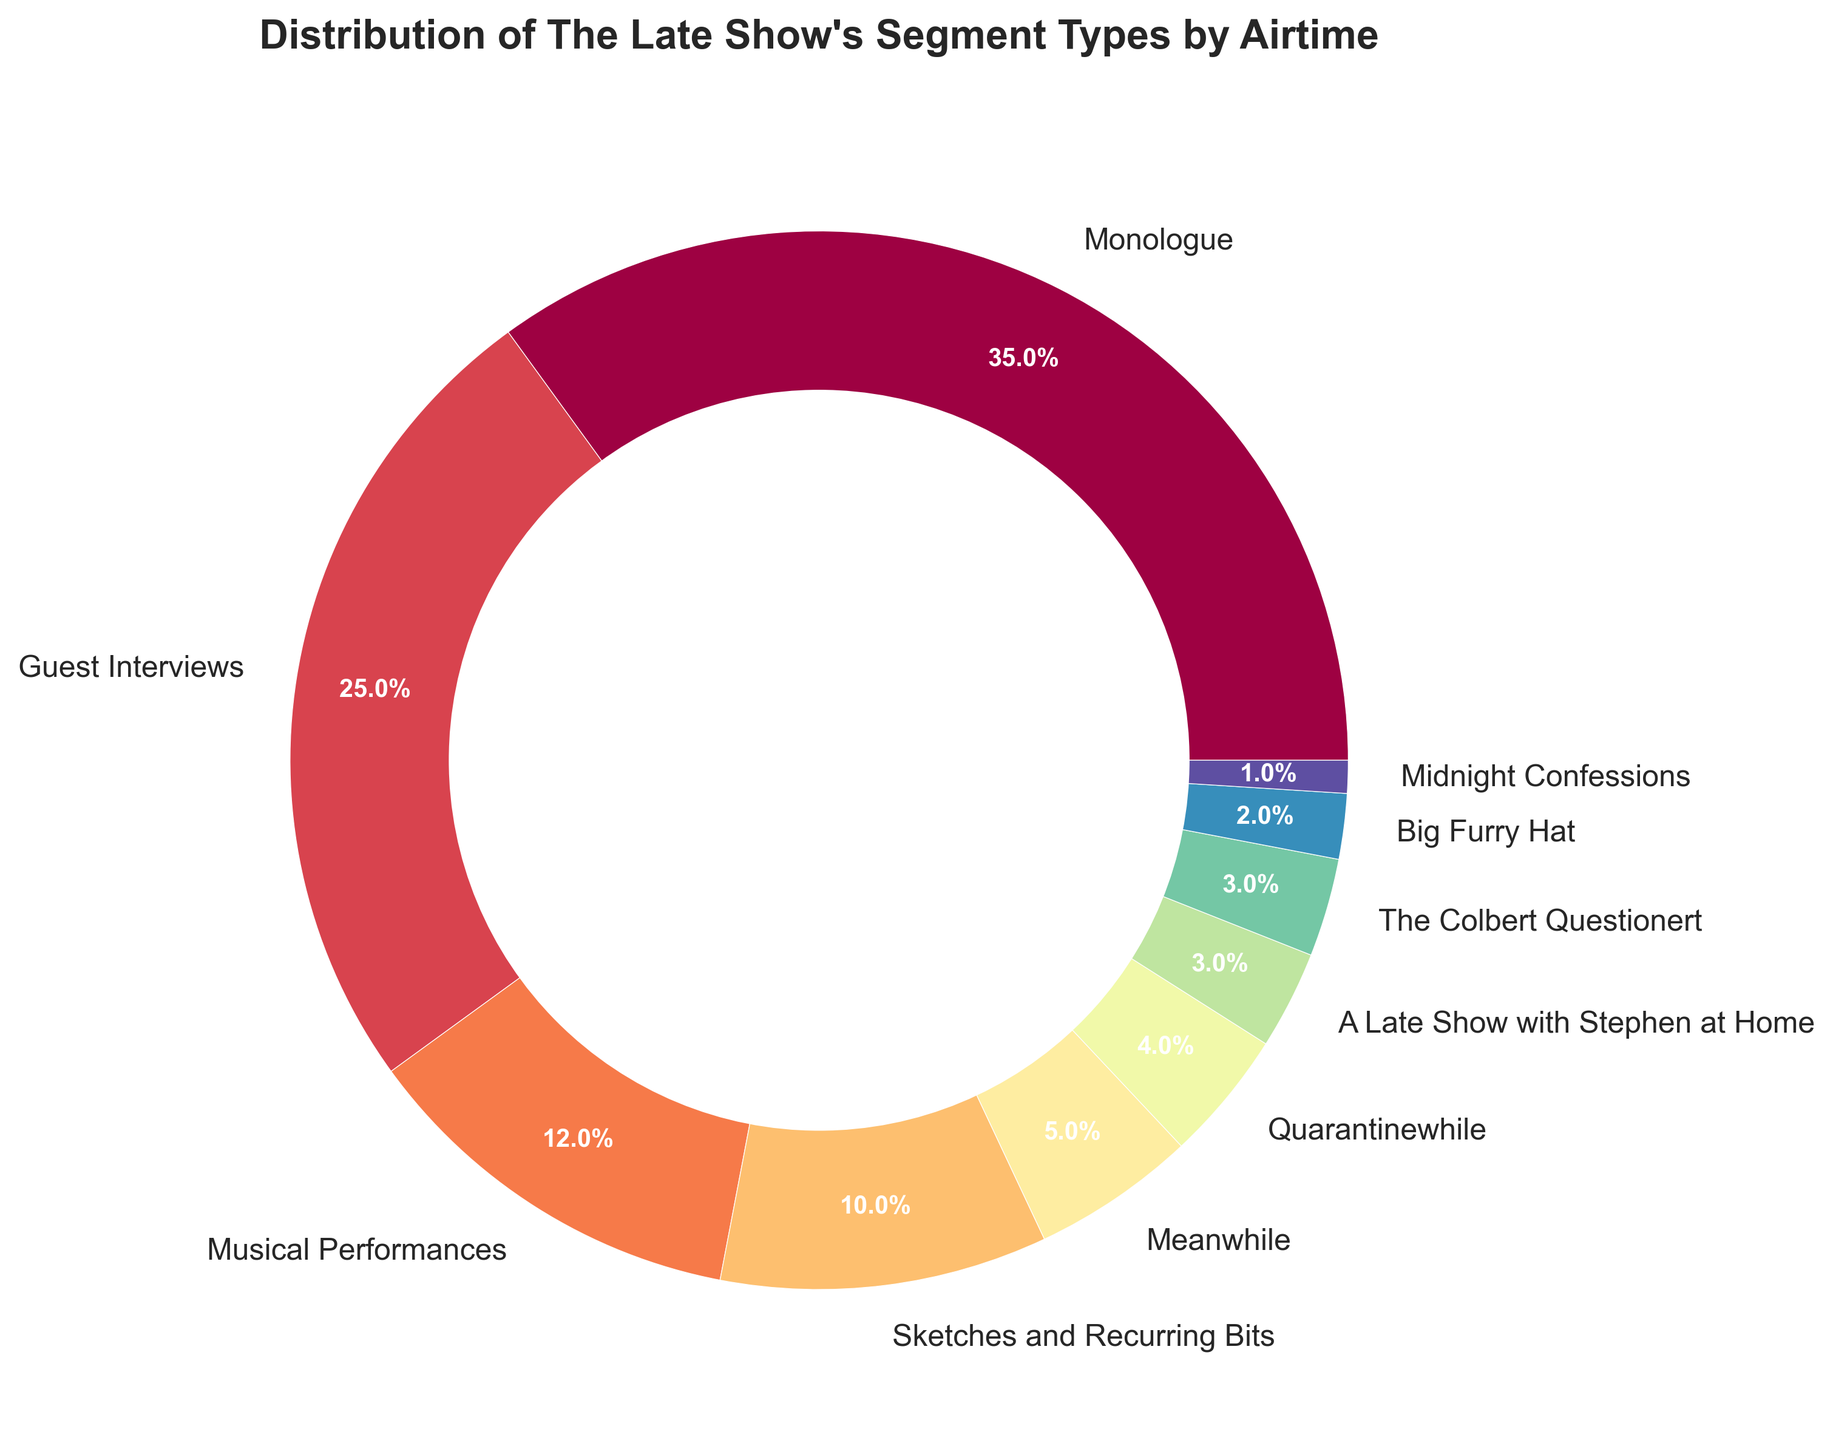What's the segment with the highest airtime percentage? By looking at the pie chart, the largest section represents the Monologue with the label showing 35%. Therefore, Monologue has the highest airtime percentage.
Answer: Monologue How much more airtime does Guest Interviews have compared to Musical Performances? The pie chart shows that Guest Interviews have 25% airtime while Musical Performances have 12%. The difference is calculated as 25% - 12% = 13%.
Answer: 13% What is the combined airtime percentage of "Quarantinewhile" and "A Late Show with Stephen at Home"? The "Quarantinewhile" segment has 4% airtime, and "A Late Show with Stephen at Home" has 3% airtime. Adding these together, 4% + 3% = 7%.
Answer: 7% What percentage of airtime is allocated to segments with less than 5% airtime each? The segments with less than 5% airtime include "Meanwhile" (5%), "Quarantinewhile" (4%), "A Late Show with Stephen at Home" (3%), "The Colbert Questionert" (3%), "Big Furry Hat" (2%) and "Midnight Confessions" (1%). Their combined airtime is 5% + 4% + 3% + 3% + 2% + 1% = 18%.
Answer: 18% Which segment has the smallest airtime percentage and what is it? The smallest section on the pie chart is labeled "Midnight Confessions" with an airtime percentage of 1%.
Answer: Midnight Confessions How does the airtime of Sketches and Recurring Bits compare to Musical Performances? Sketches and Recurring Bits have 10% airtime while Musical Performances have 12%. Musical Performances have a higher airtime.
Answer: Musical Performances have higher airtime Are there more segments with airtime percentages above 10% or below 5%? Segments above 10% include Monologue (35%), Guest Interviews (25%), Musical Performances (12%), and Sketches and Recurring Bits (10%), totaling 4 segments. Segments at or below 5% include "Meanwhile" (5%), "Quarantinewhile" (4%), "A Late Show with Stephen at Home" (3%), "The Colbert Questionert" (3%), "Big Furry Hat" (2%), and "Midnight Confessions" (1%), totaling 6 segments.
Answer: Below 5% What percentage of the airtime is devoted to segments that fall between 1% and 10%? The segments between 1% and 10% airtime include Sketches and Recurring Bits (10%), "Meanwhile" (5%), "Quarantinewhile" (4%), "A Late Show with Stephen at Home" (3%), "The Colbert Questionert" (3%), and "Big Furry Hat" (2%). Adding these together, 10% + 5% + 4% + 3% + 3% + 2% = 27%.
Answer: 27% 